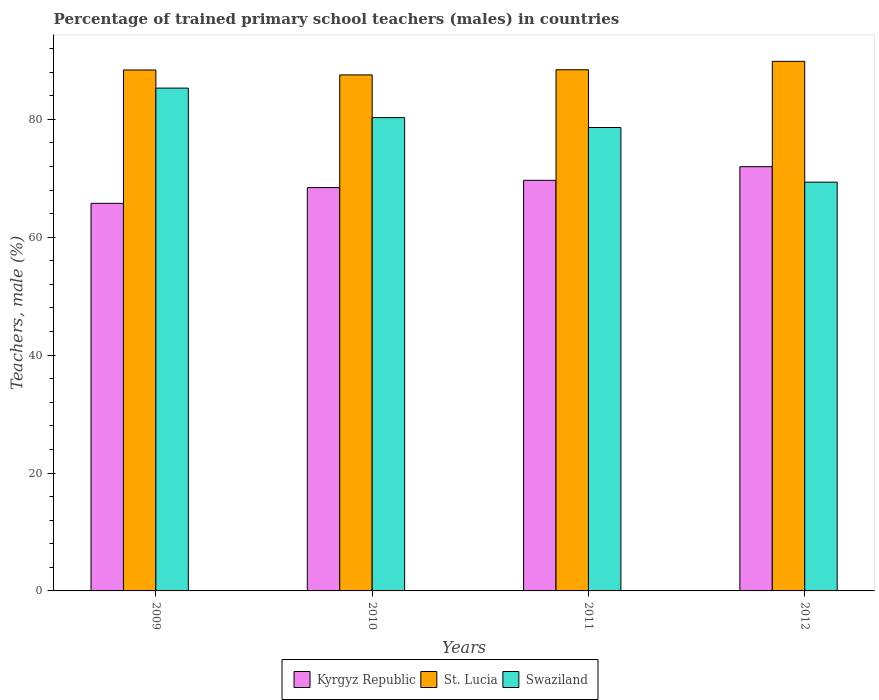How many different coloured bars are there?
Offer a terse response. 3. Are the number of bars on each tick of the X-axis equal?
Ensure brevity in your answer.  Yes. How many bars are there on the 4th tick from the right?
Your answer should be compact. 3. What is the label of the 2nd group of bars from the left?
Keep it short and to the point. 2010. In how many cases, is the number of bars for a given year not equal to the number of legend labels?
Your response must be concise. 0. What is the percentage of trained primary school teachers (males) in Swaziland in 2012?
Keep it short and to the point. 69.33. Across all years, what is the maximum percentage of trained primary school teachers (males) in Swaziland?
Provide a succinct answer. 85.29. Across all years, what is the minimum percentage of trained primary school teachers (males) in Swaziland?
Provide a short and direct response. 69.33. In which year was the percentage of trained primary school teachers (males) in Swaziland minimum?
Your answer should be very brief. 2012. What is the total percentage of trained primary school teachers (males) in Kyrgyz Republic in the graph?
Keep it short and to the point. 275.76. What is the difference between the percentage of trained primary school teachers (males) in Kyrgyz Republic in 2010 and that in 2011?
Keep it short and to the point. -1.23. What is the difference between the percentage of trained primary school teachers (males) in Kyrgyz Republic in 2011 and the percentage of trained primary school teachers (males) in St. Lucia in 2012?
Offer a very short reply. -20.18. What is the average percentage of trained primary school teachers (males) in Swaziland per year?
Make the answer very short. 78.38. In the year 2010, what is the difference between the percentage of trained primary school teachers (males) in St. Lucia and percentage of trained primary school teachers (males) in Kyrgyz Republic?
Your answer should be compact. 19.12. What is the ratio of the percentage of trained primary school teachers (males) in Kyrgyz Republic in 2010 to that in 2012?
Keep it short and to the point. 0.95. Is the difference between the percentage of trained primary school teachers (males) in St. Lucia in 2009 and 2010 greater than the difference between the percentage of trained primary school teachers (males) in Kyrgyz Republic in 2009 and 2010?
Ensure brevity in your answer.  Yes. What is the difference between the highest and the second highest percentage of trained primary school teachers (males) in St. Lucia?
Your response must be concise. 1.43. What is the difference between the highest and the lowest percentage of trained primary school teachers (males) in Swaziland?
Give a very brief answer. 15.95. Is the sum of the percentage of trained primary school teachers (males) in Swaziland in 2010 and 2012 greater than the maximum percentage of trained primary school teachers (males) in Kyrgyz Republic across all years?
Provide a succinct answer. Yes. What does the 1st bar from the left in 2012 represents?
Make the answer very short. Kyrgyz Republic. What does the 3rd bar from the right in 2010 represents?
Ensure brevity in your answer.  Kyrgyz Republic. Is it the case that in every year, the sum of the percentage of trained primary school teachers (males) in Swaziland and percentage of trained primary school teachers (males) in Kyrgyz Republic is greater than the percentage of trained primary school teachers (males) in St. Lucia?
Make the answer very short. Yes. How many bars are there?
Offer a very short reply. 12. Are the values on the major ticks of Y-axis written in scientific E-notation?
Your answer should be compact. No. Does the graph contain any zero values?
Make the answer very short. No. Does the graph contain grids?
Your response must be concise. No. Where does the legend appear in the graph?
Ensure brevity in your answer.  Bottom center. What is the title of the graph?
Keep it short and to the point. Percentage of trained primary school teachers (males) in countries. Does "Andorra" appear as one of the legend labels in the graph?
Give a very brief answer. No. What is the label or title of the Y-axis?
Offer a terse response. Teachers, male (%). What is the Teachers, male (%) of Kyrgyz Republic in 2009?
Give a very brief answer. 65.74. What is the Teachers, male (%) of St. Lucia in 2009?
Your answer should be very brief. 88.36. What is the Teachers, male (%) of Swaziland in 2009?
Your answer should be very brief. 85.29. What is the Teachers, male (%) of Kyrgyz Republic in 2010?
Keep it short and to the point. 68.41. What is the Teachers, male (%) in St. Lucia in 2010?
Your answer should be compact. 87.53. What is the Teachers, male (%) of Swaziland in 2010?
Give a very brief answer. 80.28. What is the Teachers, male (%) in Kyrgyz Republic in 2011?
Make the answer very short. 69.64. What is the Teachers, male (%) in St. Lucia in 2011?
Give a very brief answer. 88.4. What is the Teachers, male (%) in Swaziland in 2011?
Your answer should be compact. 78.6. What is the Teachers, male (%) in Kyrgyz Republic in 2012?
Make the answer very short. 71.96. What is the Teachers, male (%) of St. Lucia in 2012?
Keep it short and to the point. 89.82. What is the Teachers, male (%) in Swaziland in 2012?
Your answer should be compact. 69.33. Across all years, what is the maximum Teachers, male (%) of Kyrgyz Republic?
Provide a short and direct response. 71.96. Across all years, what is the maximum Teachers, male (%) in St. Lucia?
Give a very brief answer. 89.82. Across all years, what is the maximum Teachers, male (%) of Swaziland?
Offer a terse response. 85.29. Across all years, what is the minimum Teachers, male (%) of Kyrgyz Republic?
Provide a short and direct response. 65.74. Across all years, what is the minimum Teachers, male (%) of St. Lucia?
Provide a succinct answer. 87.53. Across all years, what is the minimum Teachers, male (%) of Swaziland?
Ensure brevity in your answer.  69.33. What is the total Teachers, male (%) of Kyrgyz Republic in the graph?
Offer a very short reply. 275.76. What is the total Teachers, male (%) of St. Lucia in the graph?
Provide a succinct answer. 354.11. What is the total Teachers, male (%) in Swaziland in the graph?
Keep it short and to the point. 313.51. What is the difference between the Teachers, male (%) in Kyrgyz Republic in 2009 and that in 2010?
Ensure brevity in your answer.  -2.67. What is the difference between the Teachers, male (%) of St. Lucia in 2009 and that in 2010?
Make the answer very short. 0.83. What is the difference between the Teachers, male (%) of Swaziland in 2009 and that in 2010?
Offer a terse response. 5. What is the difference between the Teachers, male (%) in Kyrgyz Republic in 2009 and that in 2011?
Your answer should be compact. -3.9. What is the difference between the Teachers, male (%) in St. Lucia in 2009 and that in 2011?
Give a very brief answer. -0.04. What is the difference between the Teachers, male (%) of Swaziland in 2009 and that in 2011?
Ensure brevity in your answer.  6.68. What is the difference between the Teachers, male (%) in Kyrgyz Republic in 2009 and that in 2012?
Your answer should be compact. -6.22. What is the difference between the Teachers, male (%) of St. Lucia in 2009 and that in 2012?
Provide a succinct answer. -1.46. What is the difference between the Teachers, male (%) in Swaziland in 2009 and that in 2012?
Give a very brief answer. 15.95. What is the difference between the Teachers, male (%) in Kyrgyz Republic in 2010 and that in 2011?
Make the answer very short. -1.23. What is the difference between the Teachers, male (%) in St. Lucia in 2010 and that in 2011?
Offer a very short reply. -0.87. What is the difference between the Teachers, male (%) of Swaziland in 2010 and that in 2011?
Your response must be concise. 1.68. What is the difference between the Teachers, male (%) of Kyrgyz Republic in 2010 and that in 2012?
Offer a very short reply. -3.55. What is the difference between the Teachers, male (%) in St. Lucia in 2010 and that in 2012?
Offer a very short reply. -2.3. What is the difference between the Teachers, male (%) in Swaziland in 2010 and that in 2012?
Your response must be concise. 10.95. What is the difference between the Teachers, male (%) in Kyrgyz Republic in 2011 and that in 2012?
Provide a short and direct response. -2.31. What is the difference between the Teachers, male (%) in St. Lucia in 2011 and that in 2012?
Your answer should be very brief. -1.43. What is the difference between the Teachers, male (%) in Swaziland in 2011 and that in 2012?
Provide a succinct answer. 9.27. What is the difference between the Teachers, male (%) in Kyrgyz Republic in 2009 and the Teachers, male (%) in St. Lucia in 2010?
Provide a succinct answer. -21.79. What is the difference between the Teachers, male (%) of Kyrgyz Republic in 2009 and the Teachers, male (%) of Swaziland in 2010?
Your answer should be compact. -14.54. What is the difference between the Teachers, male (%) in St. Lucia in 2009 and the Teachers, male (%) in Swaziland in 2010?
Offer a terse response. 8.08. What is the difference between the Teachers, male (%) in Kyrgyz Republic in 2009 and the Teachers, male (%) in St. Lucia in 2011?
Offer a very short reply. -22.66. What is the difference between the Teachers, male (%) in Kyrgyz Republic in 2009 and the Teachers, male (%) in Swaziland in 2011?
Give a very brief answer. -12.86. What is the difference between the Teachers, male (%) of St. Lucia in 2009 and the Teachers, male (%) of Swaziland in 2011?
Ensure brevity in your answer.  9.76. What is the difference between the Teachers, male (%) of Kyrgyz Republic in 2009 and the Teachers, male (%) of St. Lucia in 2012?
Provide a succinct answer. -24.08. What is the difference between the Teachers, male (%) in Kyrgyz Republic in 2009 and the Teachers, male (%) in Swaziland in 2012?
Provide a succinct answer. -3.59. What is the difference between the Teachers, male (%) in St. Lucia in 2009 and the Teachers, male (%) in Swaziland in 2012?
Provide a succinct answer. 19.03. What is the difference between the Teachers, male (%) in Kyrgyz Republic in 2010 and the Teachers, male (%) in St. Lucia in 2011?
Make the answer very short. -19.99. What is the difference between the Teachers, male (%) of Kyrgyz Republic in 2010 and the Teachers, male (%) of Swaziland in 2011?
Keep it short and to the point. -10.19. What is the difference between the Teachers, male (%) of St. Lucia in 2010 and the Teachers, male (%) of Swaziland in 2011?
Give a very brief answer. 8.92. What is the difference between the Teachers, male (%) in Kyrgyz Republic in 2010 and the Teachers, male (%) in St. Lucia in 2012?
Your response must be concise. -21.41. What is the difference between the Teachers, male (%) of Kyrgyz Republic in 2010 and the Teachers, male (%) of Swaziland in 2012?
Your response must be concise. -0.92. What is the difference between the Teachers, male (%) in St. Lucia in 2010 and the Teachers, male (%) in Swaziland in 2012?
Your answer should be compact. 18.19. What is the difference between the Teachers, male (%) in Kyrgyz Republic in 2011 and the Teachers, male (%) in St. Lucia in 2012?
Make the answer very short. -20.18. What is the difference between the Teachers, male (%) in Kyrgyz Republic in 2011 and the Teachers, male (%) in Swaziland in 2012?
Provide a short and direct response. 0.31. What is the difference between the Teachers, male (%) in St. Lucia in 2011 and the Teachers, male (%) in Swaziland in 2012?
Make the answer very short. 19.07. What is the average Teachers, male (%) in Kyrgyz Republic per year?
Offer a very short reply. 68.94. What is the average Teachers, male (%) in St. Lucia per year?
Ensure brevity in your answer.  88.53. What is the average Teachers, male (%) of Swaziland per year?
Your answer should be compact. 78.38. In the year 2009, what is the difference between the Teachers, male (%) in Kyrgyz Republic and Teachers, male (%) in St. Lucia?
Offer a terse response. -22.62. In the year 2009, what is the difference between the Teachers, male (%) in Kyrgyz Republic and Teachers, male (%) in Swaziland?
Offer a terse response. -19.54. In the year 2009, what is the difference between the Teachers, male (%) of St. Lucia and Teachers, male (%) of Swaziland?
Your response must be concise. 3.08. In the year 2010, what is the difference between the Teachers, male (%) in Kyrgyz Republic and Teachers, male (%) in St. Lucia?
Your response must be concise. -19.11. In the year 2010, what is the difference between the Teachers, male (%) in Kyrgyz Republic and Teachers, male (%) in Swaziland?
Your answer should be very brief. -11.87. In the year 2010, what is the difference between the Teachers, male (%) of St. Lucia and Teachers, male (%) of Swaziland?
Make the answer very short. 7.24. In the year 2011, what is the difference between the Teachers, male (%) of Kyrgyz Republic and Teachers, male (%) of St. Lucia?
Make the answer very short. -18.75. In the year 2011, what is the difference between the Teachers, male (%) in Kyrgyz Republic and Teachers, male (%) in Swaziland?
Give a very brief answer. -8.96. In the year 2011, what is the difference between the Teachers, male (%) of St. Lucia and Teachers, male (%) of Swaziland?
Provide a succinct answer. 9.79. In the year 2012, what is the difference between the Teachers, male (%) in Kyrgyz Republic and Teachers, male (%) in St. Lucia?
Make the answer very short. -17.87. In the year 2012, what is the difference between the Teachers, male (%) in Kyrgyz Republic and Teachers, male (%) in Swaziland?
Provide a succinct answer. 2.62. In the year 2012, what is the difference between the Teachers, male (%) of St. Lucia and Teachers, male (%) of Swaziland?
Provide a succinct answer. 20.49. What is the ratio of the Teachers, male (%) of Kyrgyz Republic in 2009 to that in 2010?
Provide a succinct answer. 0.96. What is the ratio of the Teachers, male (%) of St. Lucia in 2009 to that in 2010?
Your response must be concise. 1.01. What is the ratio of the Teachers, male (%) of Swaziland in 2009 to that in 2010?
Your answer should be very brief. 1.06. What is the ratio of the Teachers, male (%) of Kyrgyz Republic in 2009 to that in 2011?
Ensure brevity in your answer.  0.94. What is the ratio of the Teachers, male (%) in Swaziland in 2009 to that in 2011?
Make the answer very short. 1.08. What is the ratio of the Teachers, male (%) of Kyrgyz Republic in 2009 to that in 2012?
Your response must be concise. 0.91. What is the ratio of the Teachers, male (%) of St. Lucia in 2009 to that in 2012?
Keep it short and to the point. 0.98. What is the ratio of the Teachers, male (%) in Swaziland in 2009 to that in 2012?
Give a very brief answer. 1.23. What is the ratio of the Teachers, male (%) in Kyrgyz Republic in 2010 to that in 2011?
Your answer should be very brief. 0.98. What is the ratio of the Teachers, male (%) of St. Lucia in 2010 to that in 2011?
Your answer should be very brief. 0.99. What is the ratio of the Teachers, male (%) of Swaziland in 2010 to that in 2011?
Provide a short and direct response. 1.02. What is the ratio of the Teachers, male (%) in Kyrgyz Republic in 2010 to that in 2012?
Your answer should be very brief. 0.95. What is the ratio of the Teachers, male (%) of St. Lucia in 2010 to that in 2012?
Your answer should be compact. 0.97. What is the ratio of the Teachers, male (%) of Swaziland in 2010 to that in 2012?
Give a very brief answer. 1.16. What is the ratio of the Teachers, male (%) in Kyrgyz Republic in 2011 to that in 2012?
Offer a very short reply. 0.97. What is the ratio of the Teachers, male (%) in St. Lucia in 2011 to that in 2012?
Your answer should be compact. 0.98. What is the ratio of the Teachers, male (%) of Swaziland in 2011 to that in 2012?
Your response must be concise. 1.13. What is the difference between the highest and the second highest Teachers, male (%) in Kyrgyz Republic?
Offer a very short reply. 2.31. What is the difference between the highest and the second highest Teachers, male (%) of St. Lucia?
Provide a short and direct response. 1.43. What is the difference between the highest and the second highest Teachers, male (%) in Swaziland?
Offer a very short reply. 5. What is the difference between the highest and the lowest Teachers, male (%) in Kyrgyz Republic?
Your response must be concise. 6.22. What is the difference between the highest and the lowest Teachers, male (%) in St. Lucia?
Make the answer very short. 2.3. What is the difference between the highest and the lowest Teachers, male (%) of Swaziland?
Offer a very short reply. 15.95. 